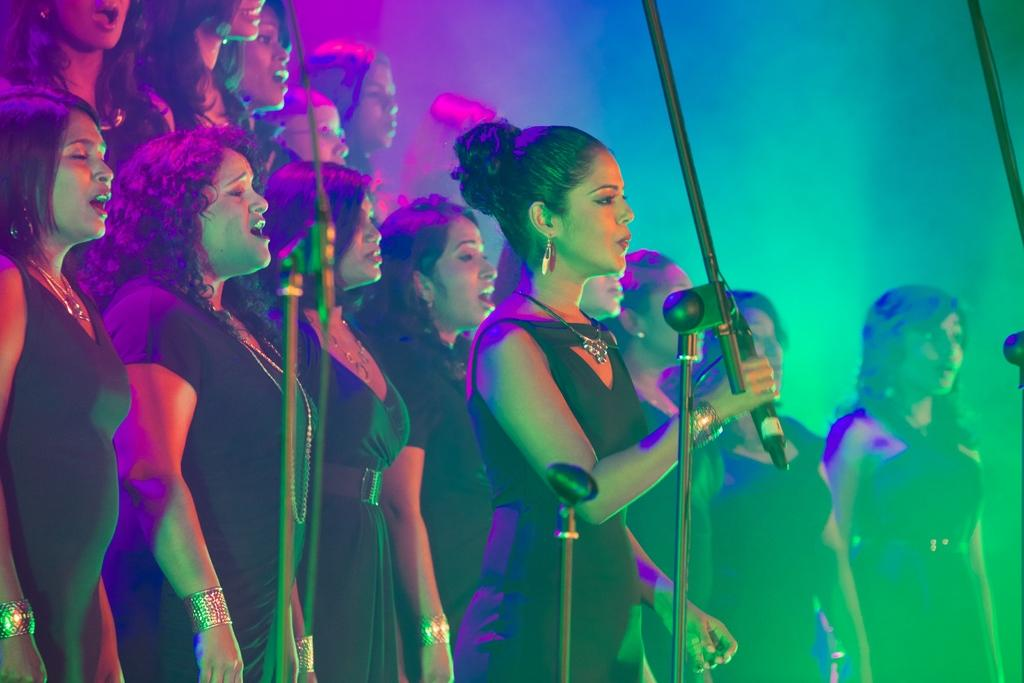What is the main subject of the image? The main subject of the image is a group of girls. What are the girls doing in the image? There are miles in front of the girls, which suggests they might be walking or running. Can you describe the girl in the foreground? There is a girl holding a mike in the foreground, which indicates that she might be a performer or speaker. What can be seen in the background of the image? There is a light focus in the background, which could be a spotlight or stage lighting. What type of yarn is the girl holding in the image? There is no yarn present in the image; the girl is holding a mike. Can you tell me how the grandfather is involved in the scene? There is no mention of a grandfather in the image or the provided facts. 